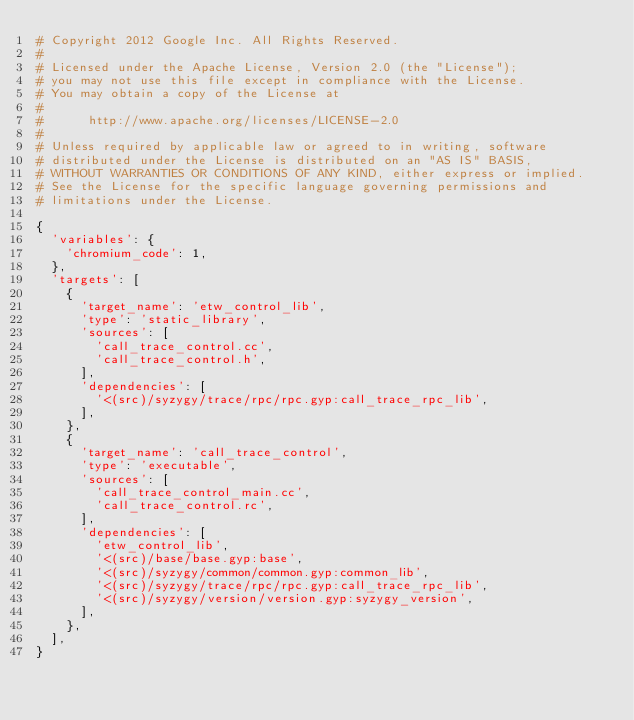<code> <loc_0><loc_0><loc_500><loc_500><_Python_># Copyright 2012 Google Inc. All Rights Reserved.
#
# Licensed under the Apache License, Version 2.0 (the "License");
# you may not use this file except in compliance with the License.
# You may obtain a copy of the License at
#
#      http://www.apache.org/licenses/LICENSE-2.0
#
# Unless required by applicable law or agreed to in writing, software
# distributed under the License is distributed on an "AS IS" BASIS,
# WITHOUT WARRANTIES OR CONDITIONS OF ANY KIND, either express or implied.
# See the License for the specific language governing permissions and
# limitations under the License.

{
  'variables': {
    'chromium_code': 1,
  },
  'targets': [
    {
      'target_name': 'etw_control_lib',
      'type': 'static_library',
      'sources': [
        'call_trace_control.cc',
        'call_trace_control.h',
      ],
      'dependencies': [
        '<(src)/syzygy/trace/rpc/rpc.gyp:call_trace_rpc_lib',
      ],
    },
    {
      'target_name': 'call_trace_control',
      'type': 'executable',
      'sources': [
        'call_trace_control_main.cc',
        'call_trace_control.rc',
      ],
      'dependencies': [
        'etw_control_lib',
        '<(src)/base/base.gyp:base',
        '<(src)/syzygy/common/common.gyp:common_lib',
        '<(src)/syzygy/trace/rpc/rpc.gyp:call_trace_rpc_lib',
        '<(src)/syzygy/version/version.gyp:syzygy_version',
      ],
    },
  ],
}
</code> 